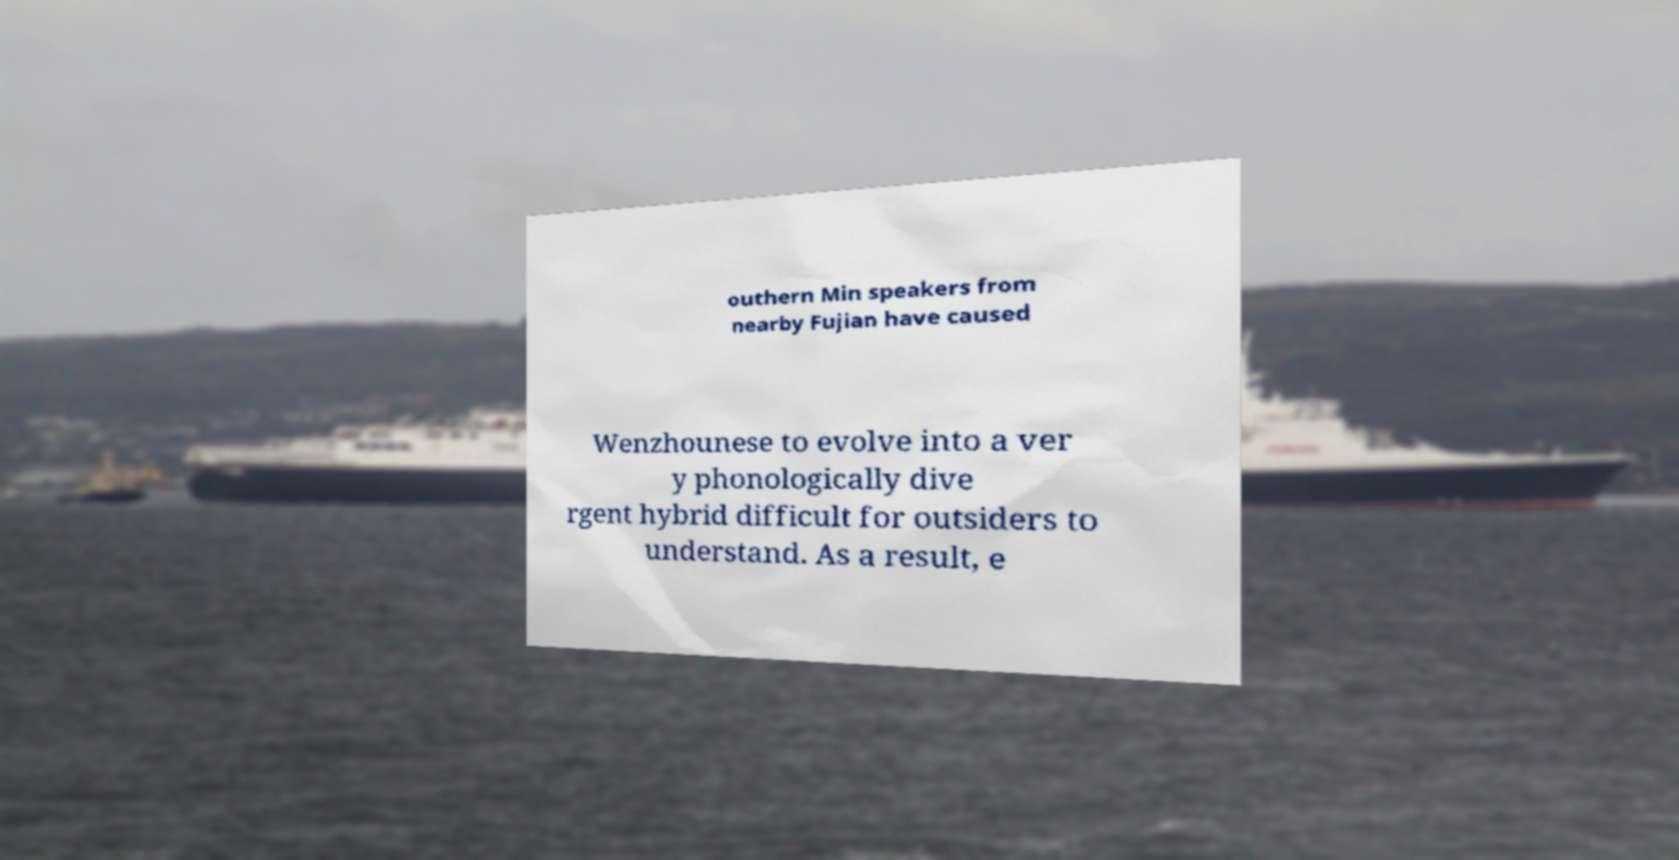There's text embedded in this image that I need extracted. Can you transcribe it verbatim? outhern Min speakers from nearby Fujian have caused Wenzhounese to evolve into a ver y phonologically dive rgent hybrid difficult for outsiders to understand. As a result, e 